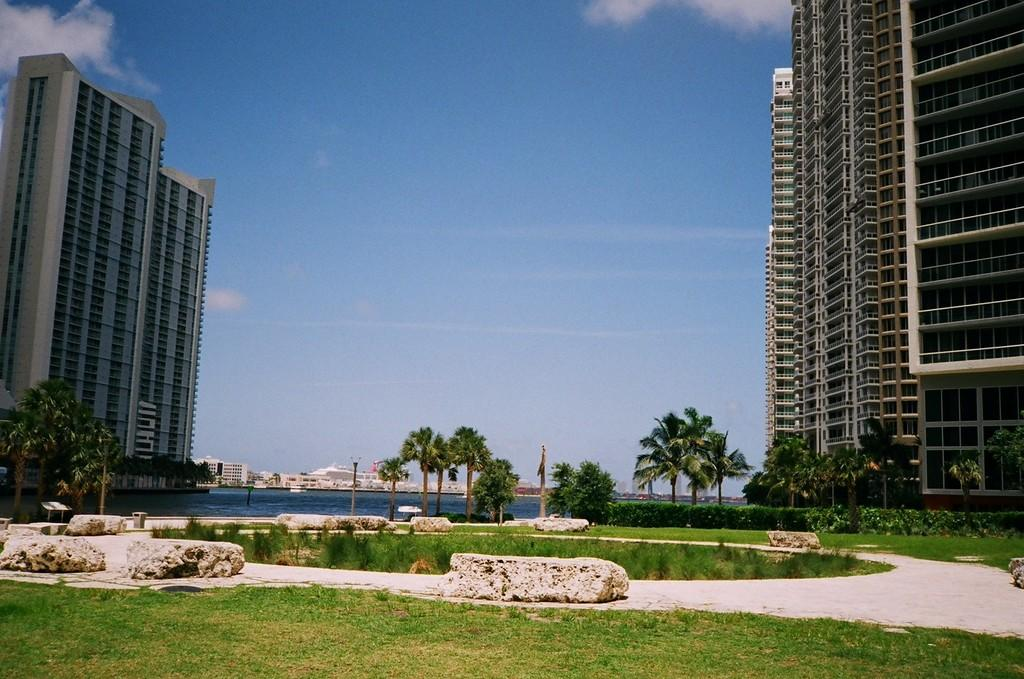What type of structures can be seen in the image? There are buildings in the image. What is located at the bottom of the image? Water, trees, and grass are present at the bottom of the image. What can be seen in the background of the image? The sky is visible in the background of the image. Where is the hydrant located in the image? There is no hydrant present in the image. Can you tell me how many insects are sitting on the buildings in the image? There are no insects visible on the buildings in the image. 